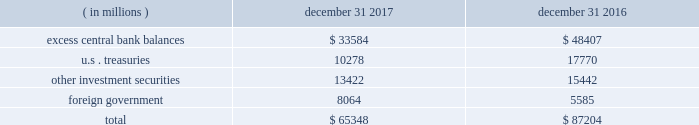Management 2019s discussion and analysis of financial condition and results of operations state street corporation | 89 $ 65.35 billion and $ 87.20 billion as of december 31 , 2017 and december 31 , 2016 , respectively .
Table 29 : components of average hqla by type of ( in millions ) december 31 , december 31 .
With respect to highly liquid short-term investments presented in the preceding table , due to the continued elevated level of client deposits as of december 31 , 2017 , we maintained cash balances in excess of regulatory requirements governing deposits with the federal reserve of approximately $ 33.58 billion at the federal reserve , the ecb and other non-u.s .
Central banks , compared to $ 48.40 billion as of december 31 , 2016 .
The lower levels of deposits with central banks as of december 31 , 2017 compared to december 31 , 2016 was due to normal deposit volatility .
Liquid securities carried in our asset liquidity include securities pledged without corresponding advances from the frbb , the fhlb , and other non- u.s .
Central banks .
State street bank is a member of the fhlb .
This membership allows for advances of liquidity in varying terms against high-quality collateral , which helps facilitate asset-and-liability management .
Access to primary , intra-day and contingent liquidity provided by these utilities is an important source of contingent liquidity with utilization subject to underlying conditions .
As of december 31 , 2017 and december 31 , 2016 , we had no outstanding primary credit borrowings from the frbb discount window or any other central bank facility , and as of the same dates , no fhlb advances were outstanding .
In addition to the securities included in our asset liquidity , we have significant amounts of other unencumbered investment securities .
The aggregate fair value of those securities was $ 66.10 billion as of december 31 , 2017 , compared to $ 54.40 billion as of december 31 , 2016 .
These securities are available sources of liquidity , although not as rapidly deployed as those included in our asset liquidity .
Measures of liquidity include lcr , nsfr and tlac which are described in "supervision and regulation" included under item 1 , business , of this form 10-k .
Uses of liquidity significant uses of our liquidity could result from the following : withdrawals of client deposits ; draw- downs of unfunded commitments to extend credit or to purchase securities , generally provided through lines of credit ; and short-duration advance facilities .
Such circumstances would generally arise under stress conditions including deterioration in credit ratings .
A recurring significant use of our liquidity involves our deployment of hqla from our investment portfolio to post collateral to financial institutions and participants in our agency lending program serving as sources of securities under our enhanced custody program .
We had unfunded commitments to extend credit with gross contractual amounts totaling $ 26.49 billion and $ 26.99 billion as of december 31 , 2017 and december 31 , 2016 , respectively .
These amounts do not reflect the value of any collateral .
As of december 31 , 2017 , approximately 72% ( 72 % ) of our unfunded commitments to extend credit expire within one year .
Since many of our commitments are expected to expire or renew without being drawn upon , the gross contractual amounts do not necessarily represent our future cash requirements .
Information about our resolution planning and the impact actions under our resolution plans could have on our liquidity is provided in "supervision and regulation" included under item 1 .
Business , of this form 10-k .
Funding deposits we provide products and services including custody , accounting , administration , daily pricing , foreign exchange services , cash management , financial asset management , securities finance and investment advisory services .
As a provider of these products and services , we generate client deposits , which have generally provided a stable , low-cost source of funds .
As a global custodian , clients place deposits with state street entities in various currencies .
As of december 31 , 2017 and december 31 , 2016 , approximately 60% ( 60 % ) of our average client deposit balances were denominated in u.s .
Dollars , approximately 20% ( 20 % ) in eur , 10% ( 10 % ) in gbp and 10% ( 10 % ) in all other currencies .
For the past several years , we have frequently experienced higher client deposit inflows toward the end of each fiscal quarter or the end of the fiscal year .
As a result , we believe average client deposit balances are more reflective of ongoing funding than period-end balances. .
What portion of the total investments is held by foreign government of december 31 , 2017? 
Computations: (8064 / 65348)
Answer: 0.1234. Management 2019s discussion and analysis of financial condition and results of operations state street corporation | 89 $ 65.35 billion and $ 87.20 billion as of december 31 , 2017 and december 31 , 2016 , respectively .
Table 29 : components of average hqla by type of ( in millions ) december 31 , december 31 .
With respect to highly liquid short-term investments presented in the preceding table , due to the continued elevated level of client deposits as of december 31 , 2017 , we maintained cash balances in excess of regulatory requirements governing deposits with the federal reserve of approximately $ 33.58 billion at the federal reserve , the ecb and other non-u.s .
Central banks , compared to $ 48.40 billion as of december 31 , 2016 .
The lower levels of deposits with central banks as of december 31 , 2017 compared to december 31 , 2016 was due to normal deposit volatility .
Liquid securities carried in our asset liquidity include securities pledged without corresponding advances from the frbb , the fhlb , and other non- u.s .
Central banks .
State street bank is a member of the fhlb .
This membership allows for advances of liquidity in varying terms against high-quality collateral , which helps facilitate asset-and-liability management .
Access to primary , intra-day and contingent liquidity provided by these utilities is an important source of contingent liquidity with utilization subject to underlying conditions .
As of december 31 , 2017 and december 31 , 2016 , we had no outstanding primary credit borrowings from the frbb discount window or any other central bank facility , and as of the same dates , no fhlb advances were outstanding .
In addition to the securities included in our asset liquidity , we have significant amounts of other unencumbered investment securities .
The aggregate fair value of those securities was $ 66.10 billion as of december 31 , 2017 , compared to $ 54.40 billion as of december 31 , 2016 .
These securities are available sources of liquidity , although not as rapidly deployed as those included in our asset liquidity .
Measures of liquidity include lcr , nsfr and tlac which are described in "supervision and regulation" included under item 1 , business , of this form 10-k .
Uses of liquidity significant uses of our liquidity could result from the following : withdrawals of client deposits ; draw- downs of unfunded commitments to extend credit or to purchase securities , generally provided through lines of credit ; and short-duration advance facilities .
Such circumstances would generally arise under stress conditions including deterioration in credit ratings .
A recurring significant use of our liquidity involves our deployment of hqla from our investment portfolio to post collateral to financial institutions and participants in our agency lending program serving as sources of securities under our enhanced custody program .
We had unfunded commitments to extend credit with gross contractual amounts totaling $ 26.49 billion and $ 26.99 billion as of december 31 , 2017 and december 31 , 2016 , respectively .
These amounts do not reflect the value of any collateral .
As of december 31 , 2017 , approximately 72% ( 72 % ) of our unfunded commitments to extend credit expire within one year .
Since many of our commitments are expected to expire or renew without being drawn upon , the gross contractual amounts do not necessarily represent our future cash requirements .
Information about our resolution planning and the impact actions under our resolution plans could have on our liquidity is provided in "supervision and regulation" included under item 1 .
Business , of this form 10-k .
Funding deposits we provide products and services including custody , accounting , administration , daily pricing , foreign exchange services , cash management , financial asset management , securities finance and investment advisory services .
As a provider of these products and services , we generate client deposits , which have generally provided a stable , low-cost source of funds .
As a global custodian , clients place deposits with state street entities in various currencies .
As of december 31 , 2017 and december 31 , 2016 , approximately 60% ( 60 % ) of our average client deposit balances were denominated in u.s .
Dollars , approximately 20% ( 20 % ) in eur , 10% ( 10 % ) in gbp and 10% ( 10 % ) in all other currencies .
For the past several years , we have frequently experienced higher client deposit inflows toward the end of each fiscal quarter or the end of the fiscal year .
As a result , we believe average client deposit balances are more reflective of ongoing funding than period-end balances. .
What is the percent change excess central bank balances from 2016 to 2017? 
Computations: (1 - (33584 / 48407))
Answer: 0.30622. Management 2019s discussion and analysis of financial condition and results of operations state street corporation | 89 $ 65.35 billion and $ 87.20 billion as of december 31 , 2017 and december 31 , 2016 , respectively .
Table 29 : components of average hqla by type of ( in millions ) december 31 , december 31 .
With respect to highly liquid short-term investments presented in the preceding table , due to the continued elevated level of client deposits as of december 31 , 2017 , we maintained cash balances in excess of regulatory requirements governing deposits with the federal reserve of approximately $ 33.58 billion at the federal reserve , the ecb and other non-u.s .
Central banks , compared to $ 48.40 billion as of december 31 , 2016 .
The lower levels of deposits with central banks as of december 31 , 2017 compared to december 31 , 2016 was due to normal deposit volatility .
Liquid securities carried in our asset liquidity include securities pledged without corresponding advances from the frbb , the fhlb , and other non- u.s .
Central banks .
State street bank is a member of the fhlb .
This membership allows for advances of liquidity in varying terms against high-quality collateral , which helps facilitate asset-and-liability management .
Access to primary , intra-day and contingent liquidity provided by these utilities is an important source of contingent liquidity with utilization subject to underlying conditions .
As of december 31 , 2017 and december 31 , 2016 , we had no outstanding primary credit borrowings from the frbb discount window or any other central bank facility , and as of the same dates , no fhlb advances were outstanding .
In addition to the securities included in our asset liquidity , we have significant amounts of other unencumbered investment securities .
The aggregate fair value of those securities was $ 66.10 billion as of december 31 , 2017 , compared to $ 54.40 billion as of december 31 , 2016 .
These securities are available sources of liquidity , although not as rapidly deployed as those included in our asset liquidity .
Measures of liquidity include lcr , nsfr and tlac which are described in "supervision and regulation" included under item 1 , business , of this form 10-k .
Uses of liquidity significant uses of our liquidity could result from the following : withdrawals of client deposits ; draw- downs of unfunded commitments to extend credit or to purchase securities , generally provided through lines of credit ; and short-duration advance facilities .
Such circumstances would generally arise under stress conditions including deterioration in credit ratings .
A recurring significant use of our liquidity involves our deployment of hqla from our investment portfolio to post collateral to financial institutions and participants in our agency lending program serving as sources of securities under our enhanced custody program .
We had unfunded commitments to extend credit with gross contractual amounts totaling $ 26.49 billion and $ 26.99 billion as of december 31 , 2017 and december 31 , 2016 , respectively .
These amounts do not reflect the value of any collateral .
As of december 31 , 2017 , approximately 72% ( 72 % ) of our unfunded commitments to extend credit expire within one year .
Since many of our commitments are expected to expire or renew without being drawn upon , the gross contractual amounts do not necessarily represent our future cash requirements .
Information about our resolution planning and the impact actions under our resolution plans could have on our liquidity is provided in "supervision and regulation" included under item 1 .
Business , of this form 10-k .
Funding deposits we provide products and services including custody , accounting , administration , daily pricing , foreign exchange services , cash management , financial asset management , securities finance and investment advisory services .
As a provider of these products and services , we generate client deposits , which have generally provided a stable , low-cost source of funds .
As a global custodian , clients place deposits with state street entities in various currencies .
As of december 31 , 2017 and december 31 , 2016 , approximately 60% ( 60 % ) of our average client deposit balances were denominated in u.s .
Dollars , approximately 20% ( 20 % ) in eur , 10% ( 10 % ) in gbp and 10% ( 10 % ) in all other currencies .
For the past several years , we have frequently experienced higher client deposit inflows toward the end of each fiscal quarter or the end of the fiscal year .
As a result , we believe average client deposit balances are more reflective of ongoing funding than period-end balances. .
What portion of the total investments is held in u.s . treasuries as of december 31 , 2017? 
Computations: (10278 / 65348)
Answer: 0.15728. 